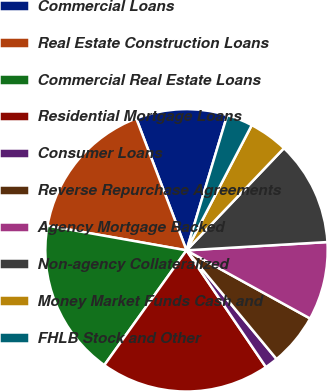Convert chart to OTSL. <chart><loc_0><loc_0><loc_500><loc_500><pie_chart><fcel>Commercial Loans<fcel>Real Estate Construction Loans<fcel>Commercial Real Estate Loans<fcel>Residential Mortgage Loans<fcel>Consumer Loans<fcel>Reverse Repurchase Agreements<fcel>Agency Mortgage Backed<fcel>Non-agency Collateralized<fcel>Money Market Funds Cash and<fcel>FHLB Stock and Other<nl><fcel>10.45%<fcel>16.42%<fcel>17.91%<fcel>19.4%<fcel>1.5%<fcel>5.97%<fcel>8.96%<fcel>11.94%<fcel>4.48%<fcel>2.99%<nl></chart> 